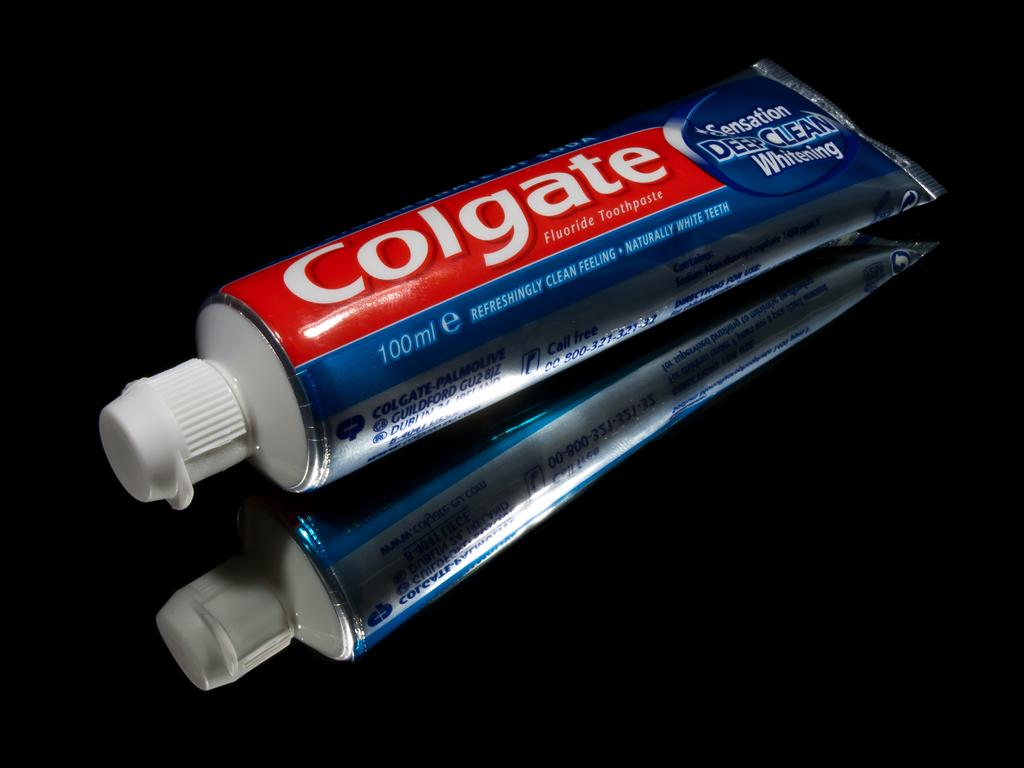<image>
Render a clear and concise summary of the photo. A tube of Colgate Deep Clean lyng on a black surface. 